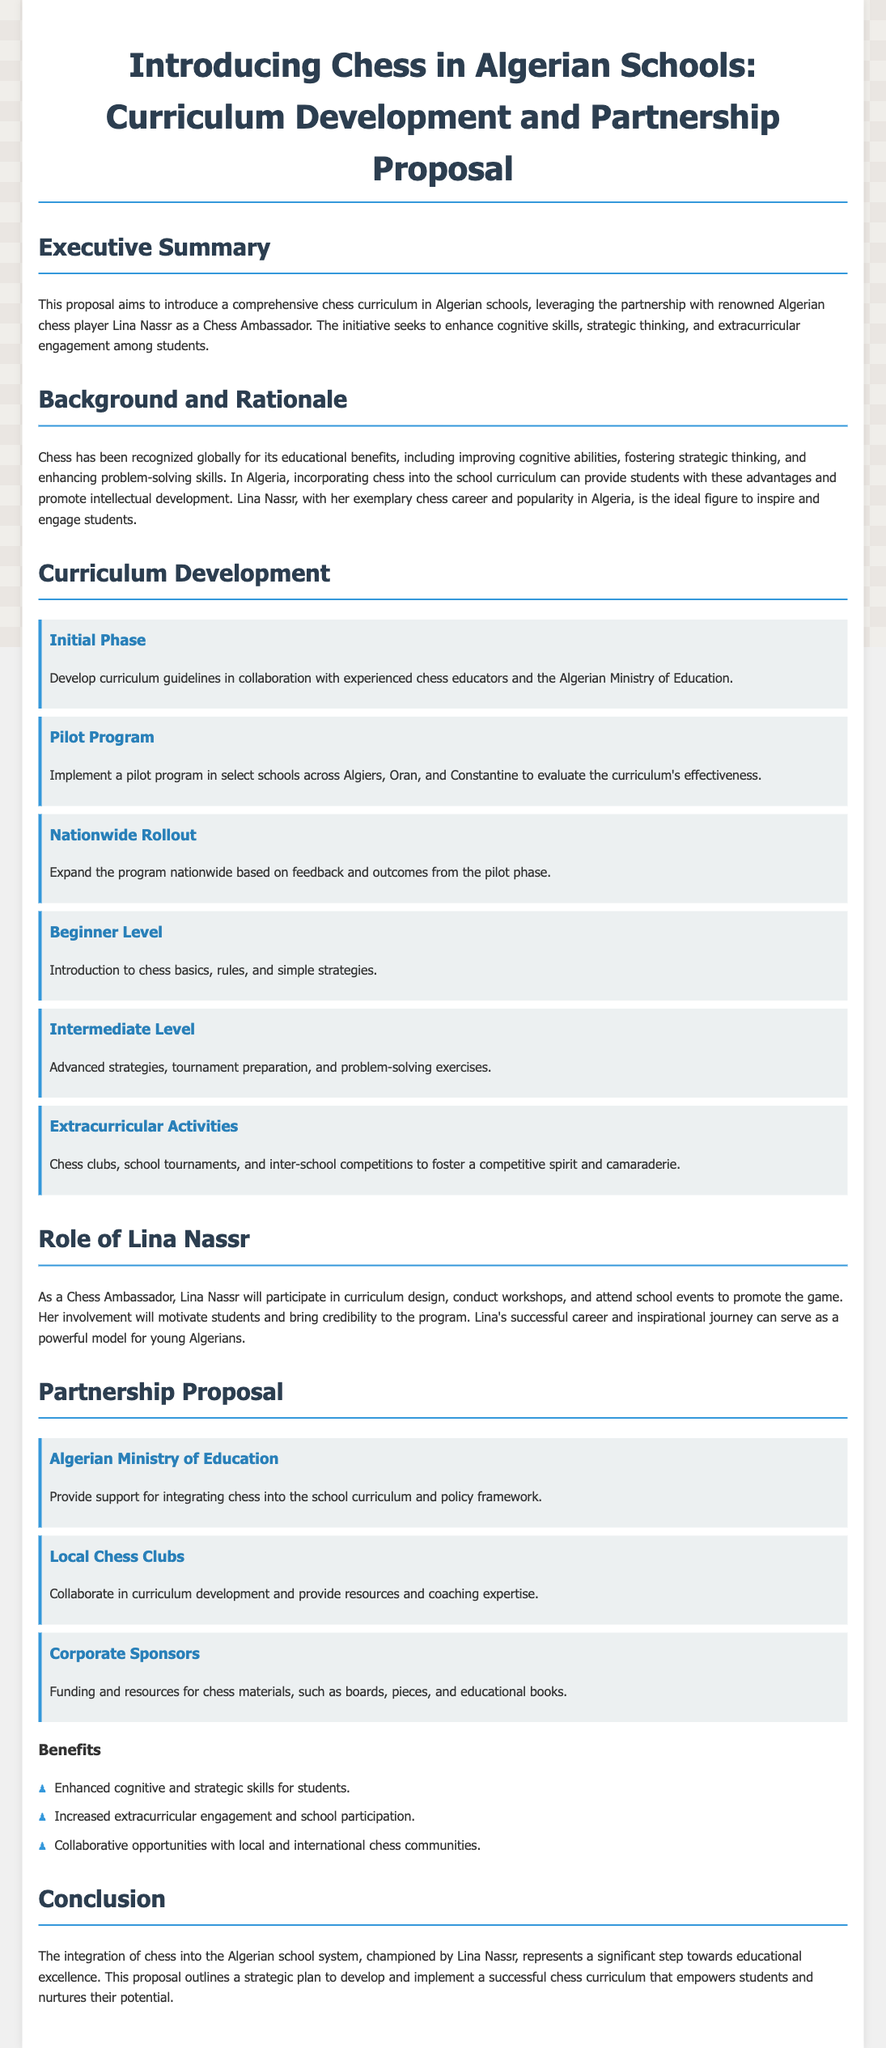what is the title of the proposal? The title of the proposal is provided in the header of the document.
Answer: Introducing Chess in Algerian Schools: Curriculum Development and Partnership Proposal who is the chess ambassador mentioned in the proposal? The document specifies who the chess ambassador is.
Answer: Lina Nassr what is one key benefit of introducing chess in schools, according to the proposal? The proposal lists benefits, including enhanced skills for students.
Answer: Enhanced cognitive and strategic skills for students what is the first phase of curriculum development? The document outlines phases in the curriculum development section.
Answer: Initial Phase which three cities are mentioned for the pilot program implementation? The proposal indicates specific locations for the pilot program.
Answer: Algiers, Oran, and Constantine how many stakeholder categories are listed in the proposal? The stakeholders section reveals the number of categories involved.
Answer: Three what type of activities are encouraged as part of the chess curriculum? The proposal mentions specific extracurricular activities associated with chess.
Answer: Chess clubs, school tournaments, and inter-school competitions what is the aim of involving Lina Nassr in the chess program? The document explains the role of Lina Nassr in the program.
Answer: Motivate students and bring credibility to the program 